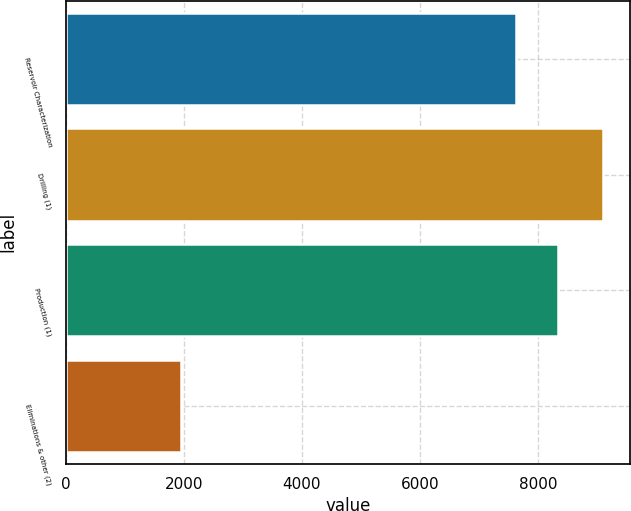Convert chart to OTSL. <chart><loc_0><loc_0><loc_500><loc_500><bar_chart><fcel>Reservoir Characterization<fcel>Drilling (1)<fcel>Production (1)<fcel>Eliminations & other (2)<nl><fcel>7621<fcel>9093<fcel>8334.5<fcel>1958<nl></chart> 